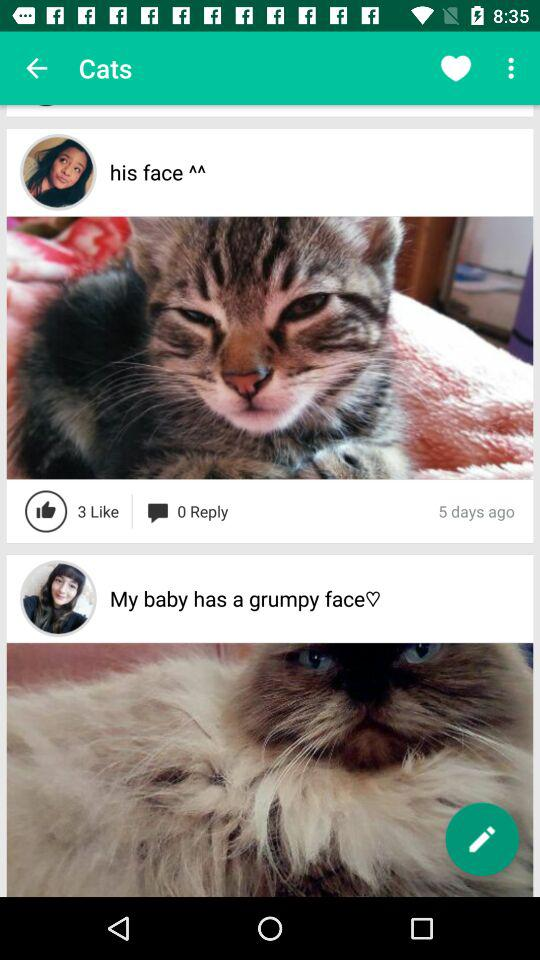How many reply are there? There are 0 reply. 